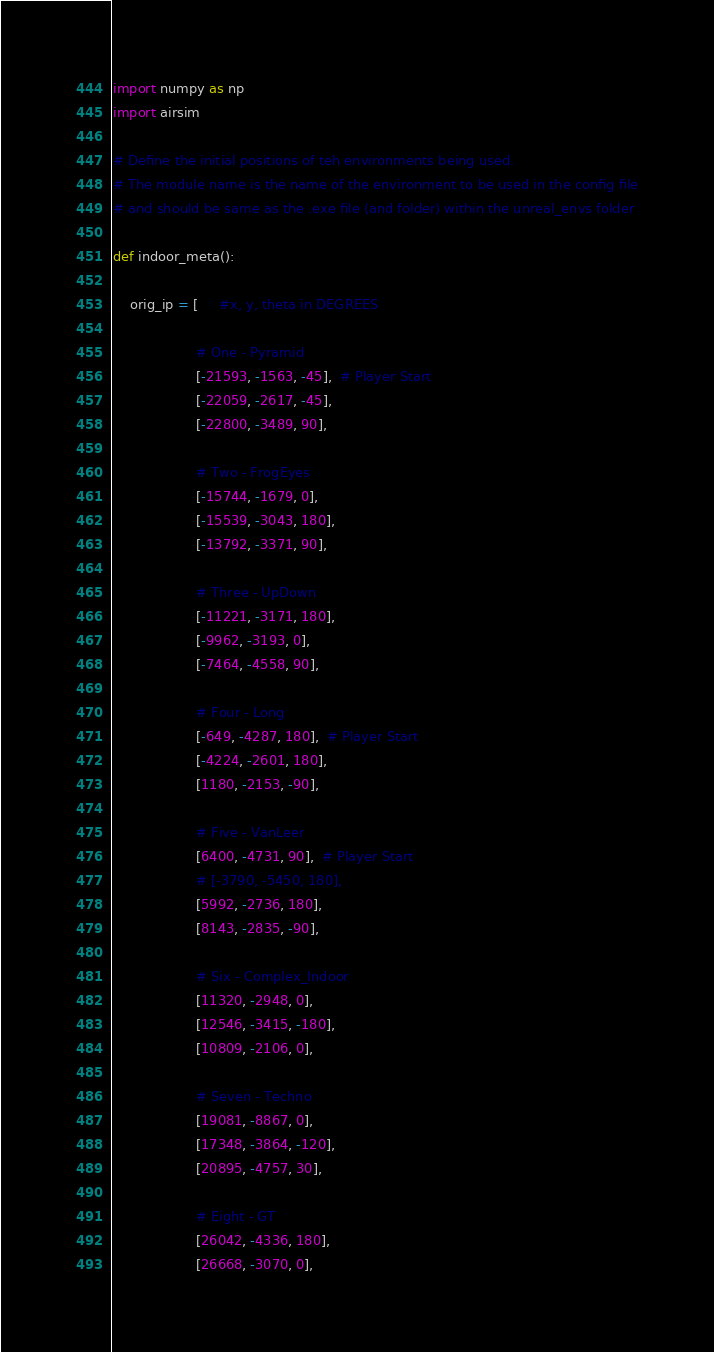Convert code to text. <code><loc_0><loc_0><loc_500><loc_500><_Python_>import numpy as np
import airsim

# Define the initial positions of teh environments being used.
# The module name is the name of the environment to be used in the config file
# and should be same as the .exe file (and folder) within the unreal_envs folder

def indoor_meta():

    orig_ip = [     #x, y, theta in DEGREES

                    # One - Pyramid
                    [-21593, -1563, -45],  # Player Start
                    [-22059, -2617, -45],
                    [-22800, -3489, 90],

                    # Two - FrogEyes
                    [-15744, -1679, 0],
                    [-15539, -3043, 180],
                    [-13792, -3371, 90],

                    # Three - UpDown
                    [-11221, -3171, 180],
                    [-9962, -3193, 0],
                    [-7464, -4558, 90],

                    # Four - Long
                    [-649, -4287, 180],  # Player Start
                    [-4224, -2601, 180],
                    [1180, -2153, -90],

                    # Five - VanLeer
                    [6400, -4731, 90],  # Player Start
                    # [-3790, -5450, 180],
                    [5992, -2736, 180],
                    [8143, -2835, -90],

                    # Six - Complex_Indoor
                    [11320, -2948, 0],
                    [12546, -3415, -180],
                    [10809, -2106, 0],

                    # Seven - Techno
                    [19081, -8867, 0],
                    [17348, -3864, -120],
                    [20895, -4757, 30],

                    # Eight - GT
                    [26042, -4336, 180],
                    [26668, -3070, 0],</code> 